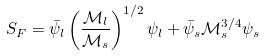Convert formula to latex. <formula><loc_0><loc_0><loc_500><loc_500>S _ { F } = \bar { \psi } _ { l } \left ( \frac { \mathcal { M } _ { l } } { \mathcal { M } _ { s } } \right ) ^ { 1 / 2 } \psi _ { l } + \bar { \psi } _ { s } \mathcal { M } _ { s } ^ { 3 / 4 } \psi _ { s }</formula> 